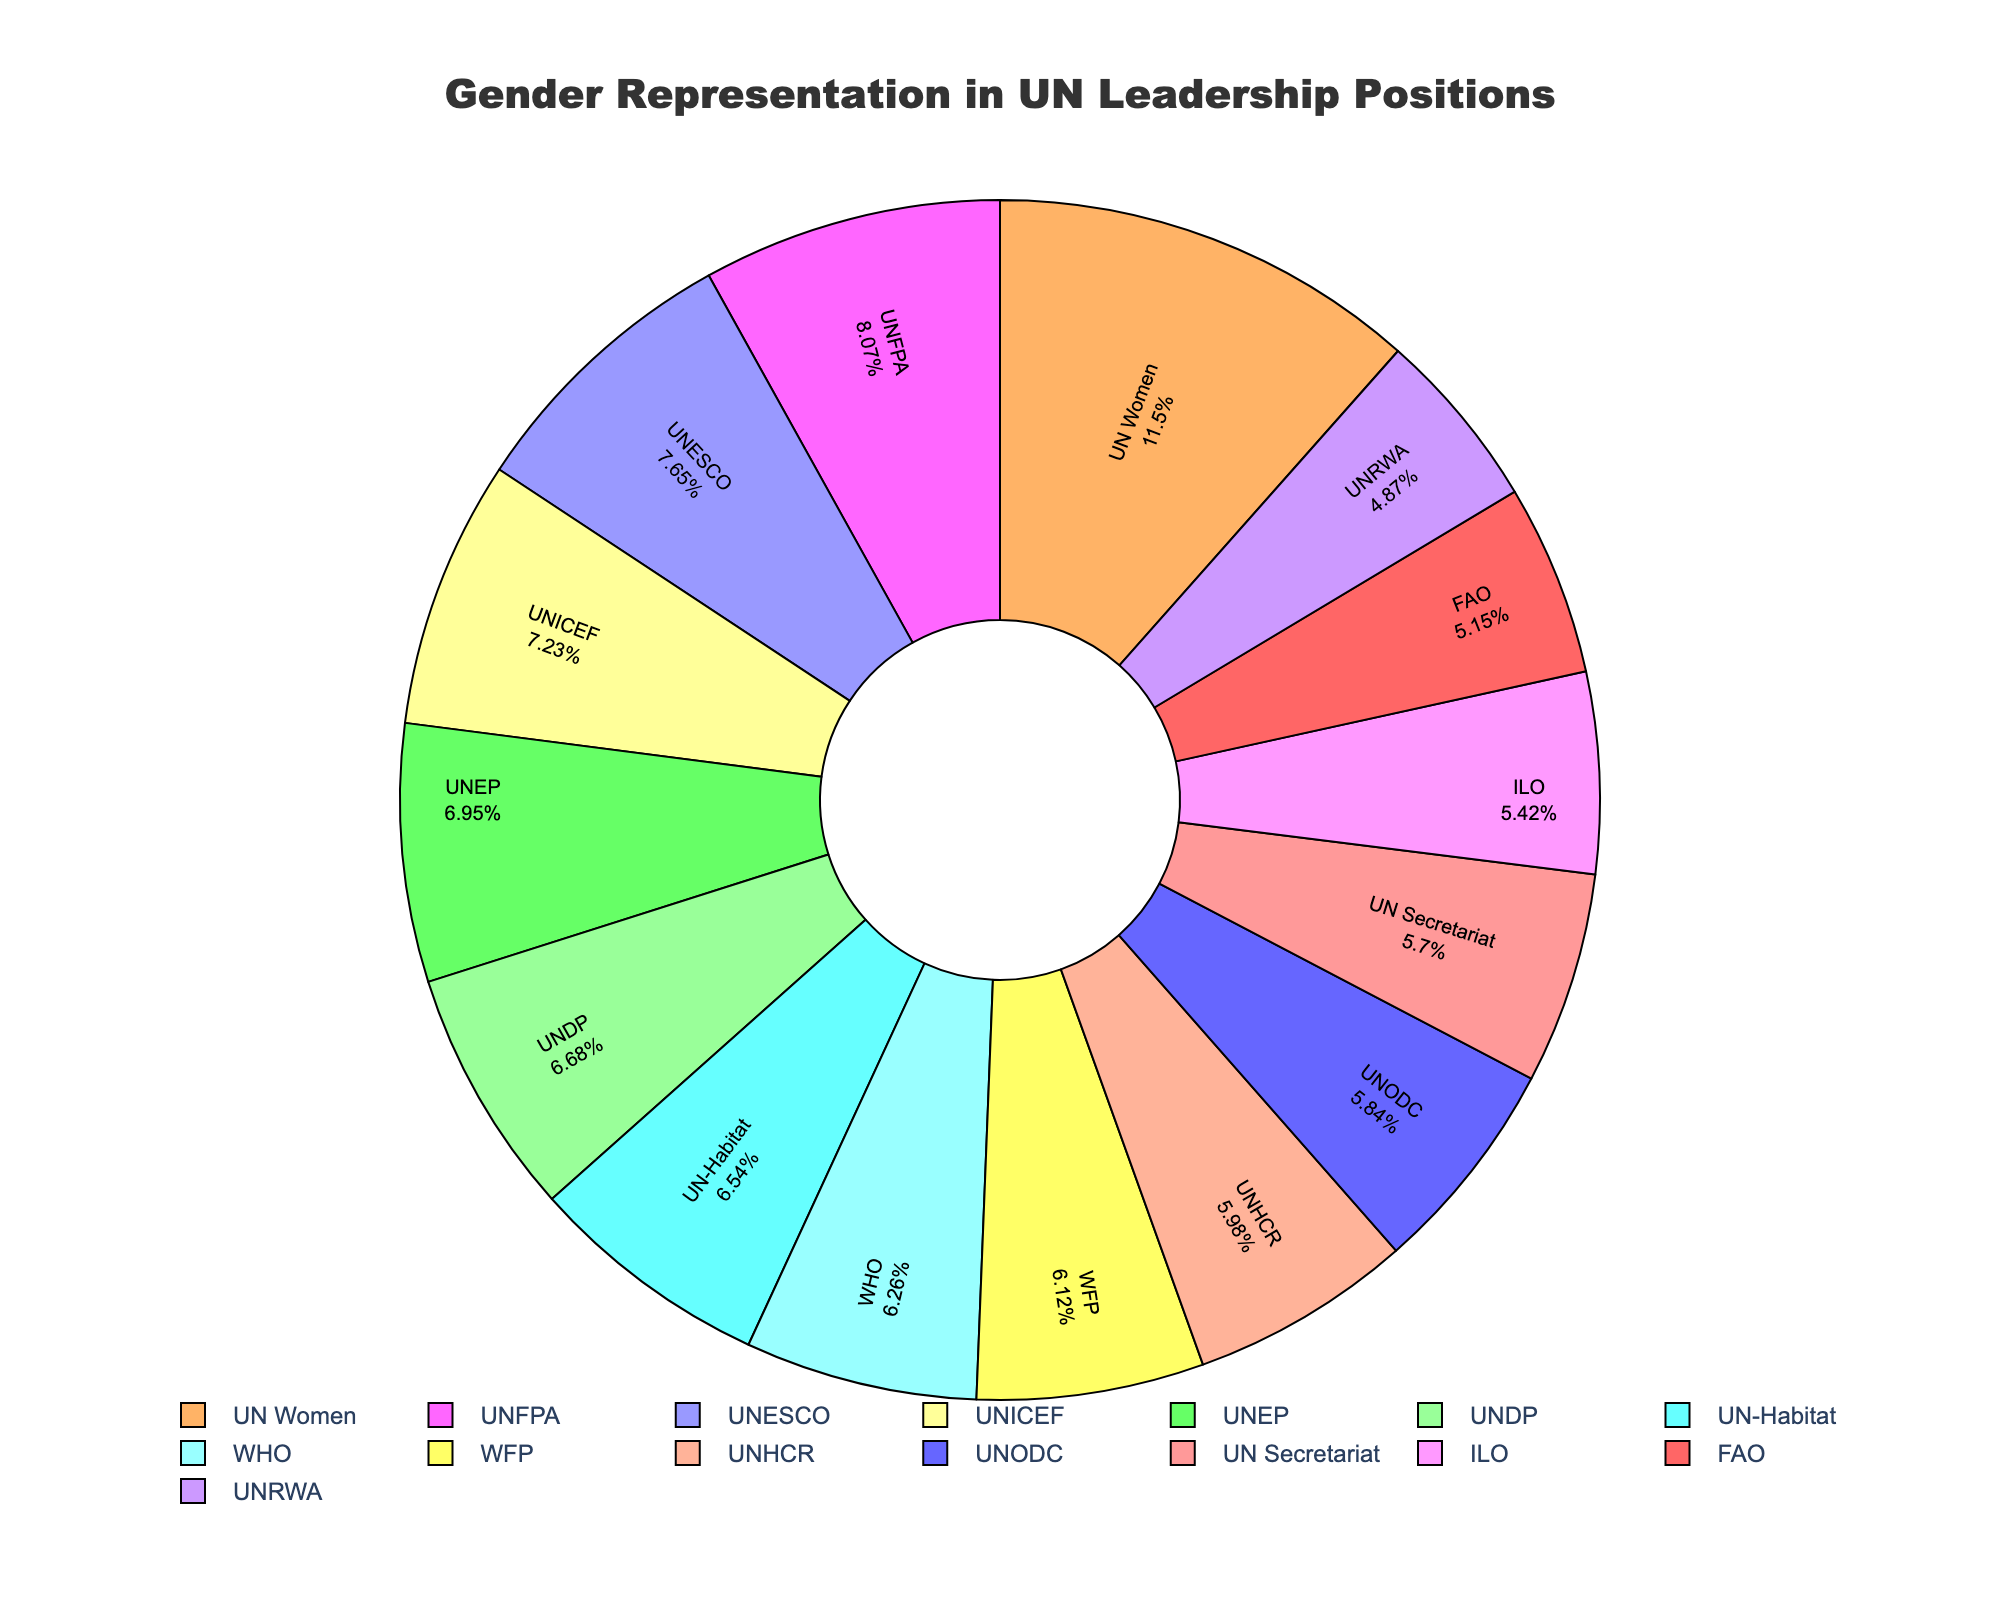Which department has the highest female representation? By looking at the sections of the pie chart labeled with percentages, the department with the highest female representation (83%) is UN Women.
Answer: UN Women What is the average female representation across all departments? First, sum the percentages for all departments: (41 + 83 + 52 + 48 + 45 + 55 + 39 + 37 + 43 + 44 + 50 + 47 + 42 + 58 + 35) = 719. Then, divide by the number of departments (15). The average is 719/15 ≈ 47.93
Answer: 47.93% Which two departments have the closest female representation? By comparing the percentages, the closest female representations are between WHO (45%) and WFP (44%) with only a 1% difference.
Answer: WHO and WFP How does the female representation in UNDP compare to that in UNICEF? UNDP has 48% female representation, and UNICEF has 52%. Thus, female representation in UNDP is 4% lower than in UNICEF.
Answer: 4% lower What is the combined female representation of UN Secretariat, ILO, and FAO? Sum the percentages for UN Secretariat (41%), ILO (39%), and FAO (37%). The combined representation is 41 + 39 + 37 = 117
Answer: 117% Between UNEP and UNFPA, which has a higher female representation and by how much? UNEP has 50% and UNFPA has 58%. Therefore, UNFPA has a higher representation by 58 - 50 = 8%.
Answer: UNFPA, 8% Which department has the lowest female representation and what is it? By reviewing the percentages, the department with the lowest female representation (35%) is UNRWA.
Answer: UNRWA, 35% What is the range of female representation percentages across all departments? The range is the difference between the highest and lowest values. The highest is 83% (UN Women) and the lowest is 35% (UNRWA). The range is 83 - 35 = 48.
Answer: 48 Which department's representation is shown in red? Identify the section colored in red in the pie chart and match it with the department label. The red section corresponds to UN Secretariat, which has 41% female representation.
Answer: UN Secretariat 